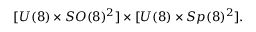Convert formula to latex. <formula><loc_0><loc_0><loc_500><loc_500>[ U ( 8 ) \times S O ( 8 ) ^ { 2 } ] \times [ U ( 8 ) \times S p ( 8 ) ^ { 2 } ] .</formula> 